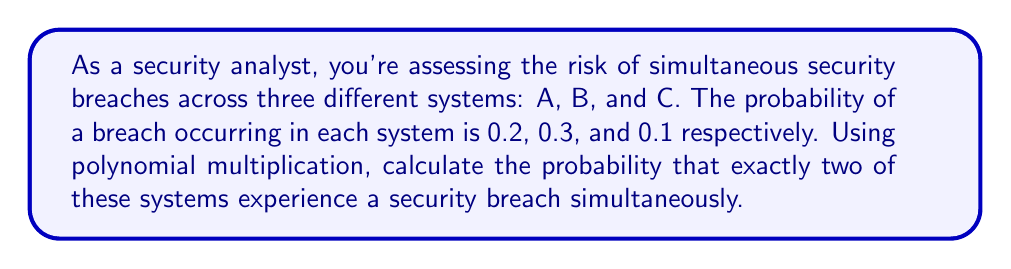Give your solution to this math problem. To solve this problem, we'll use polynomial multiplication to represent all possible outcomes and then identify the coefficient of the term that represents exactly two breaches.

1) Let's represent each system with a binomial:
   System A: $(0.8 + 0.2x)$
   System B: $(0.7 + 0.3x)$
   System C: $(0.9 + 0.1x)$

   Where $x$ represents a breach, and the constant term represents no breach.

2) Multiply these polynomials:

   $$(0.8 + 0.2x)(0.7 + 0.3x)(0.9 + 0.1x)$$

3) Expand the multiplication:

   $$0.8(0.7 + 0.3x)(0.9 + 0.1x) + 0.2x(0.7 + 0.3x)(0.9 + 0.1x)$$
   
   $$= 0.8(0.63 + 0.27x + 0.07x + 0.03x^2) + 0.2x(0.63 + 0.27x + 0.07x + 0.03x^2)$$
   
   $$= 0.504 + 0.216x + 0.056x + 0.024x^2 + 0.126x + 0.054x^2 + 0.014x^2 + 0.006x^3$$

4) Collect like terms:

   $$0.504 + 0.398x + 0.092x^2 + 0.006x^3$$

5) The coefficient of $x^2$ (0.092) represents the probability of exactly two breaches occurring simultaneously.
Answer: The probability of exactly two systems experiencing a security breach simultaneously is 0.092 or 9.2%. 